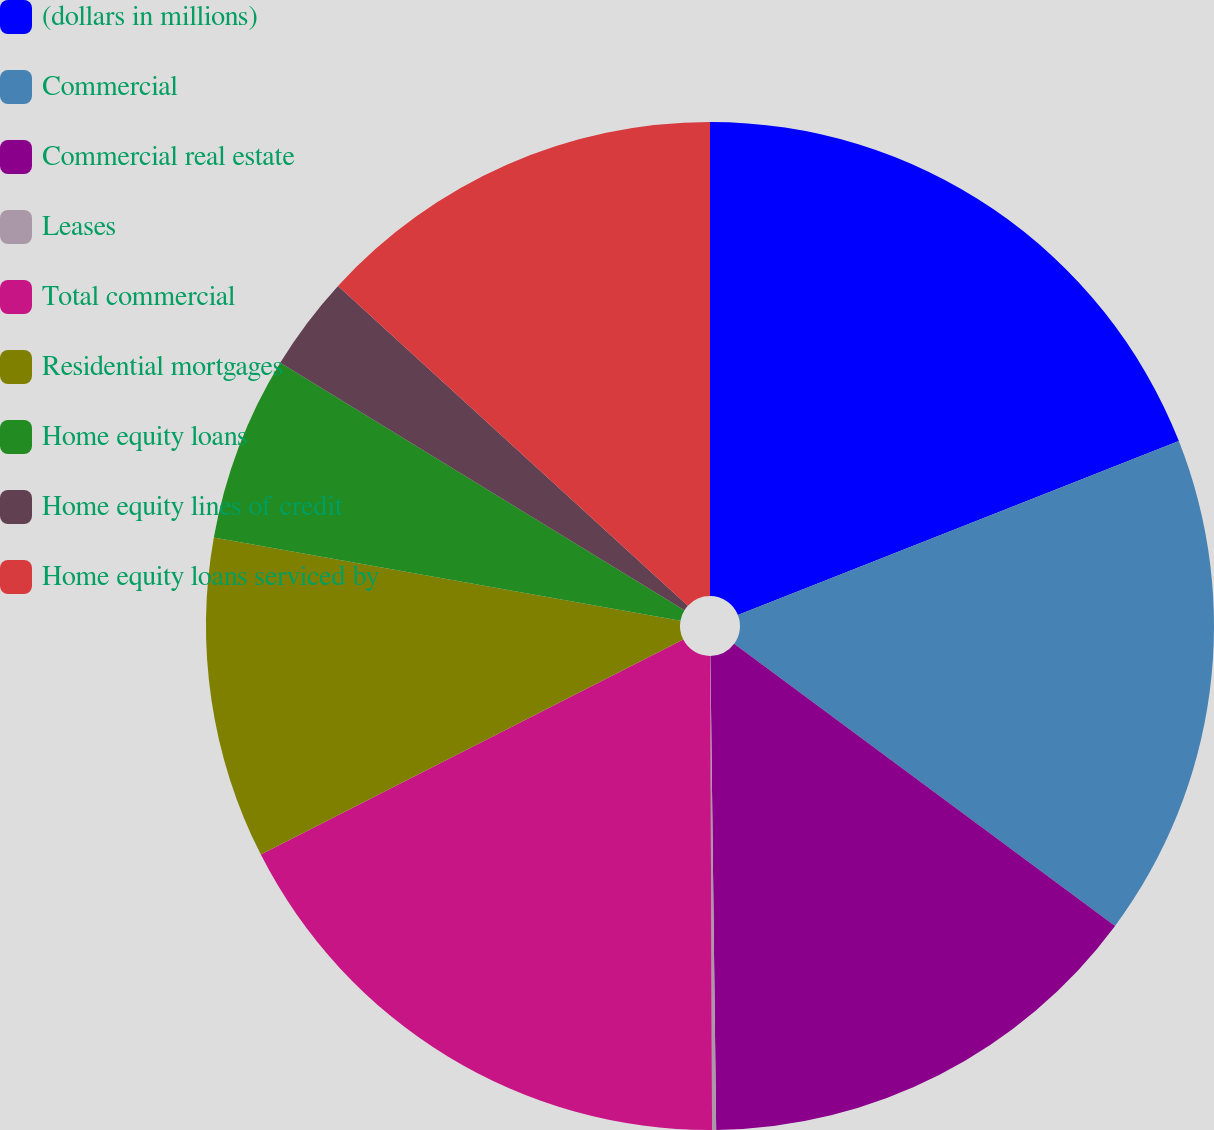Convert chart to OTSL. <chart><loc_0><loc_0><loc_500><loc_500><pie_chart><fcel>(dollars in millions)<fcel>Commercial<fcel>Commercial real estate<fcel>Leases<fcel>Total commercial<fcel>Residential mortgages<fcel>Home equity loans<fcel>Home equity lines of credit<fcel>Home equity loans serviced by<nl><fcel>19.02%<fcel>16.12%<fcel>14.66%<fcel>0.13%<fcel>17.57%<fcel>10.3%<fcel>5.94%<fcel>3.04%<fcel>13.21%<nl></chart> 